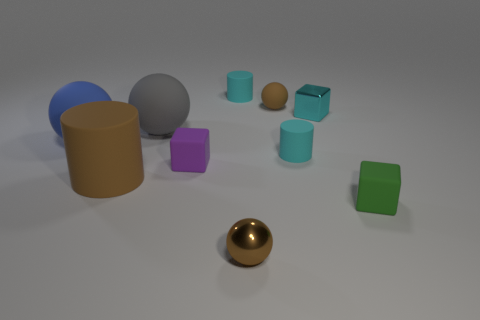Subtract all small cyan cylinders. How many cylinders are left? 1 Subtract all blue cubes. How many cyan cylinders are left? 2 Subtract 1 balls. How many balls are left? 3 Subtract all brown cylinders. How many cylinders are left? 2 Subtract all cylinders. How many objects are left? 7 Subtract all blue blocks. Subtract all green cylinders. How many blocks are left? 3 Add 5 green things. How many green things are left? 6 Add 1 tiny shiny blocks. How many tiny shiny blocks exist? 2 Subtract 0 blue cylinders. How many objects are left? 10 Subtract all blue matte spheres. Subtract all big gray matte balls. How many objects are left? 8 